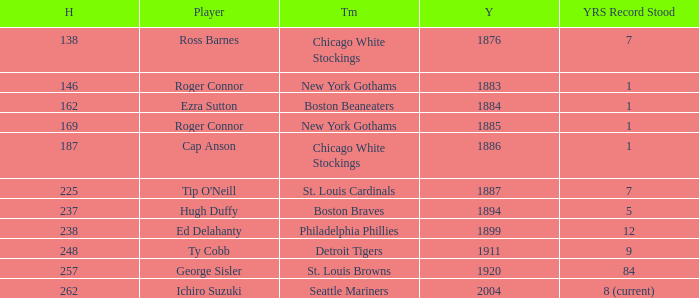Name the player with 238 hits and years after 1885 Ed Delahanty. 